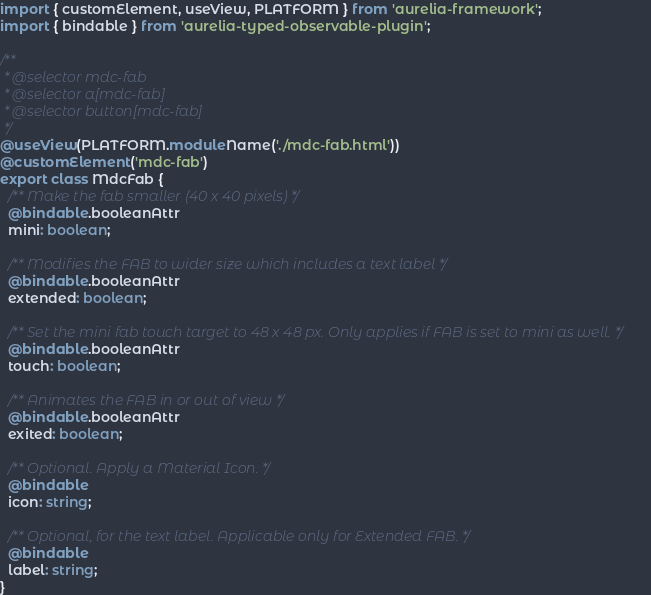<code> <loc_0><loc_0><loc_500><loc_500><_TypeScript_>import { customElement, useView, PLATFORM } from 'aurelia-framework';
import { bindable } from 'aurelia-typed-observable-plugin';

/**
 * @selector mdc-fab
 * @selector a[mdc-fab]
 * @selector button[mdc-fab]
 */
@useView(PLATFORM.moduleName('./mdc-fab.html'))
@customElement('mdc-fab')
export class MdcFab {
  /** Make the fab smaller (40 x 40 pixels) */
  @bindable.booleanAttr
  mini: boolean;

  /** Modifies the FAB to wider size which includes a text label */
  @bindable.booleanAttr
  extended: boolean;

  /** Set the mini fab touch target to 48 x 48 px. Only applies if FAB is set to mini as well. */
  @bindable.booleanAttr
  touch: boolean;

  /** Animates the FAB in or out of view */
  @bindable.booleanAttr
  exited: boolean;

  /** Optional. Apply a Material Icon. */
  @bindable
  icon: string;

  /** Optional, for the text label. Applicable only for Extended FAB. */
  @bindable
  label: string;
}
</code> 